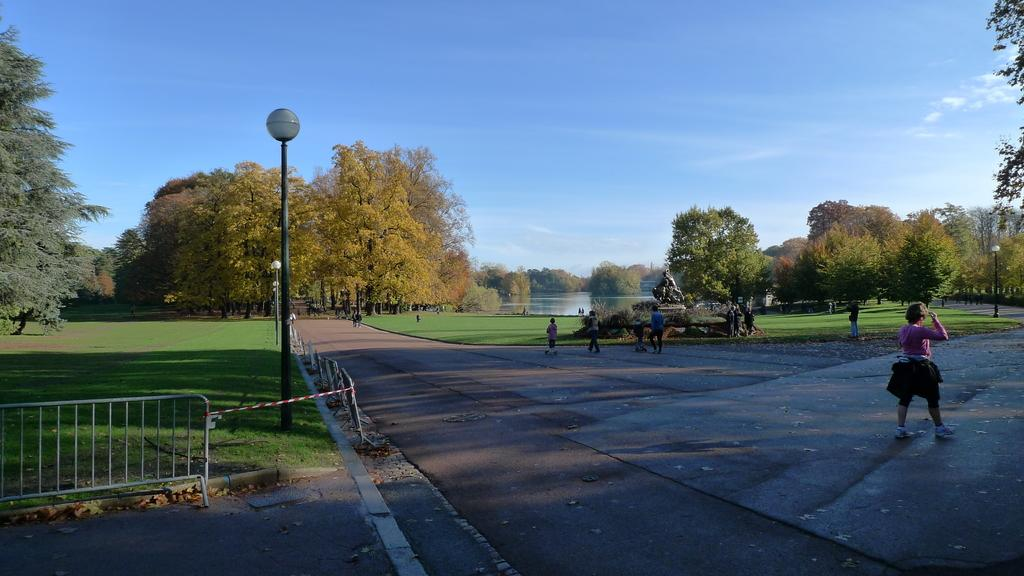How many people are in the image? There are people in the image, but the exact number is not specified. What type of surface can be seen in the image? There is a road and ground with grass visible in the image. What type of vegetation is present in the image? There are trees in the image. What type of structures can be seen in the image? There are poles and a statue in the image. What type of lighting is present in the image? There are lights in the image. What type of water feature is present in the image? There is water visible in the image. What type of barrier is present in the image? There is fencing in the image. What type of sky is visible in the image? The sky with clouds is visible in the image. Can you describe the taste of the fairies in the image? There are no fairies present in the image, so it is not possible to describe their taste. What type of work are the people in the image doing? The image does not show the people performing any specific work, so it is not possible to describe their work. 